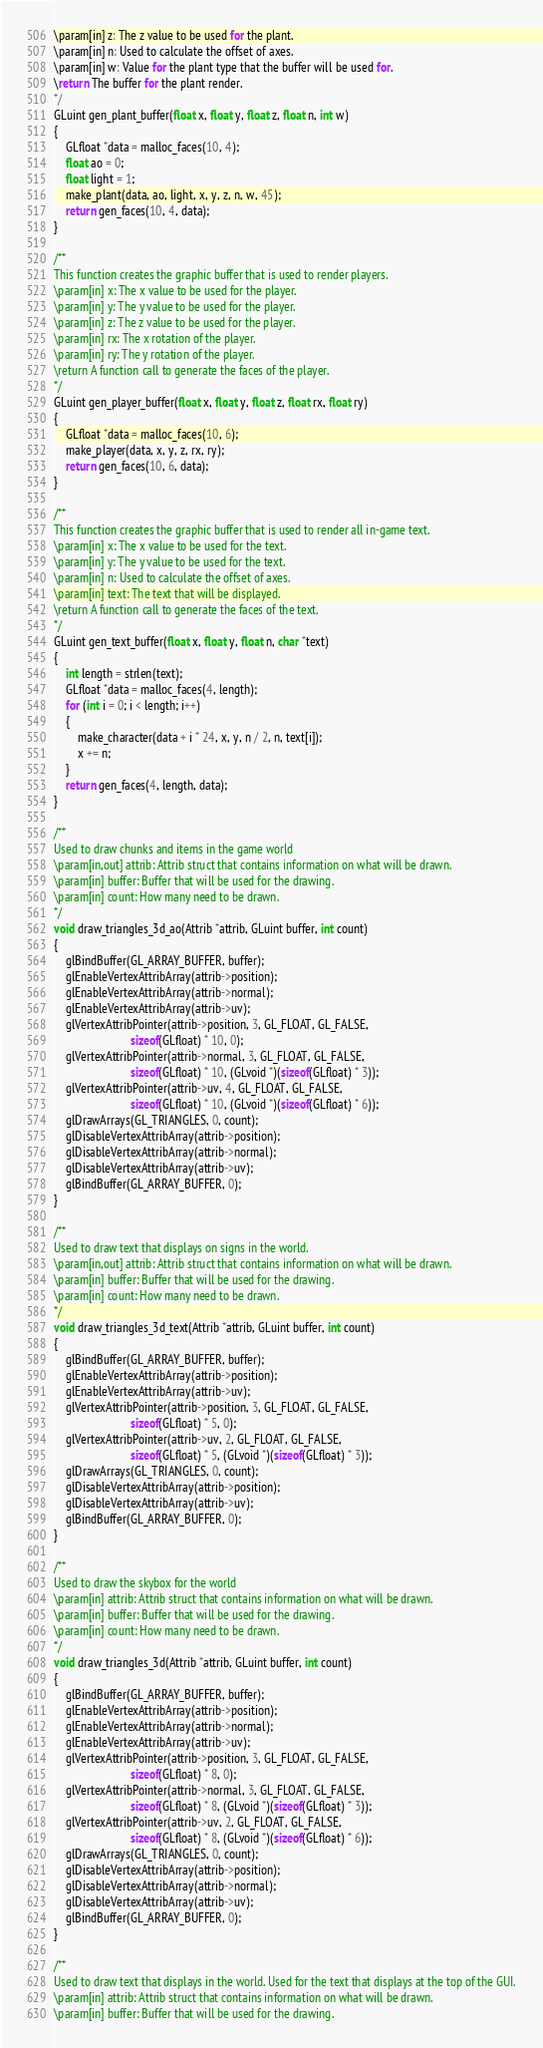<code> <loc_0><loc_0><loc_500><loc_500><_C_>\param[in] z: The z value to be used for the plant.
\param[in] n: Used to calculate the offset of axes.
\param[in] w: Value for the plant type that the buffer will be used for.
\return The buffer for the plant render.
*/
GLuint gen_plant_buffer(float x, float y, float z, float n, int w)
{
    GLfloat *data = malloc_faces(10, 4);
    float ao = 0;
    float light = 1;
    make_plant(data, ao, light, x, y, z, n, w, 45);
    return gen_faces(10, 4, data);
}

/**
This function creates the graphic buffer that is used to render players.
\param[in] x: The x value to be used for the player.
\param[in] y: The y value to be used for the player.
\param[in] z: The z value to be used for the player.
\param[in] rx: The x rotation of the player.
\param[in] ry: The y rotation of the player.
\return A function call to generate the faces of the player.
*/
GLuint gen_player_buffer(float x, float y, float z, float rx, float ry)
{
    GLfloat *data = malloc_faces(10, 6);
    make_player(data, x, y, z, rx, ry);
    return gen_faces(10, 6, data);
}

/**
This function creates the graphic buffer that is used to render all in-game text.
\param[in] x: The x value to be used for the text.
\param[in] y: The y value to be used for the text.
\param[in] n: Used to calculate the offset of axes.
\param[in] text: The text that will be displayed.
\return A function call to generate the faces of the text.
*/
GLuint gen_text_buffer(float x, float y, float n, char *text)
{
    int length = strlen(text);
    GLfloat *data = malloc_faces(4, length);
    for (int i = 0; i < length; i++)
    {
        make_character(data + i * 24, x, y, n / 2, n, text[i]);
        x += n;
    }
    return gen_faces(4, length, data);
}

/**
Used to draw chunks and items in the game world
\param[in,out] attrib: Attrib struct that contains information on what will be drawn.
\param[in] buffer: Buffer that will be used for the drawing.
\param[in] count: How many need to be drawn.
*/
void draw_triangles_3d_ao(Attrib *attrib, GLuint buffer, int count)
{
    glBindBuffer(GL_ARRAY_BUFFER, buffer);
    glEnableVertexAttribArray(attrib->position);
    glEnableVertexAttribArray(attrib->normal);
    glEnableVertexAttribArray(attrib->uv);
    glVertexAttribPointer(attrib->position, 3, GL_FLOAT, GL_FALSE,
                          sizeof(GLfloat) * 10, 0);
    glVertexAttribPointer(attrib->normal, 3, GL_FLOAT, GL_FALSE,
                          sizeof(GLfloat) * 10, (GLvoid *)(sizeof(GLfloat) * 3));
    glVertexAttribPointer(attrib->uv, 4, GL_FLOAT, GL_FALSE,
                          sizeof(GLfloat) * 10, (GLvoid *)(sizeof(GLfloat) * 6));
    glDrawArrays(GL_TRIANGLES, 0, count);
    glDisableVertexAttribArray(attrib->position);
    glDisableVertexAttribArray(attrib->normal);
    glDisableVertexAttribArray(attrib->uv);
    glBindBuffer(GL_ARRAY_BUFFER, 0);
}

/**
Used to draw text that displays on signs in the world.
\param[in,out] attrib: Attrib struct that contains information on what will be drawn.
\param[in] buffer: Buffer that will be used for the drawing.
\param[in] count: How many need to be drawn.
*/
void draw_triangles_3d_text(Attrib *attrib, GLuint buffer, int count)
{
    glBindBuffer(GL_ARRAY_BUFFER, buffer);
    glEnableVertexAttribArray(attrib->position);
    glEnableVertexAttribArray(attrib->uv);
    glVertexAttribPointer(attrib->position, 3, GL_FLOAT, GL_FALSE,
                          sizeof(GLfloat) * 5, 0);
    glVertexAttribPointer(attrib->uv, 2, GL_FLOAT, GL_FALSE,
                          sizeof(GLfloat) * 5, (GLvoid *)(sizeof(GLfloat) * 3));
    glDrawArrays(GL_TRIANGLES, 0, count);
    glDisableVertexAttribArray(attrib->position);
    glDisableVertexAttribArray(attrib->uv);
    glBindBuffer(GL_ARRAY_BUFFER, 0);
}

/**
Used to draw the skybox for the world
\param[in] attrib: Attrib struct that contains information on what will be drawn.
\param[in] buffer: Buffer that will be used for the drawing.
\param[in] count: How many need to be drawn.
*/
void draw_triangles_3d(Attrib *attrib, GLuint buffer, int count)
{
    glBindBuffer(GL_ARRAY_BUFFER, buffer);
    glEnableVertexAttribArray(attrib->position);
    glEnableVertexAttribArray(attrib->normal);
    glEnableVertexAttribArray(attrib->uv);
    glVertexAttribPointer(attrib->position, 3, GL_FLOAT, GL_FALSE,
                          sizeof(GLfloat) * 8, 0);
    glVertexAttribPointer(attrib->normal, 3, GL_FLOAT, GL_FALSE,
                          sizeof(GLfloat) * 8, (GLvoid *)(sizeof(GLfloat) * 3));
    glVertexAttribPointer(attrib->uv, 2, GL_FLOAT, GL_FALSE,
                          sizeof(GLfloat) * 8, (GLvoid *)(sizeof(GLfloat) * 6));
    glDrawArrays(GL_TRIANGLES, 0, count);
    glDisableVertexAttribArray(attrib->position);
    glDisableVertexAttribArray(attrib->normal);
    glDisableVertexAttribArray(attrib->uv);
    glBindBuffer(GL_ARRAY_BUFFER, 0);
}

/**
Used to draw text that displays in the world. Used for the text that displays at the top of the GUI.
\param[in] attrib: Attrib struct that contains information on what will be drawn.
\param[in] buffer: Buffer that will be used for the drawing.</code> 